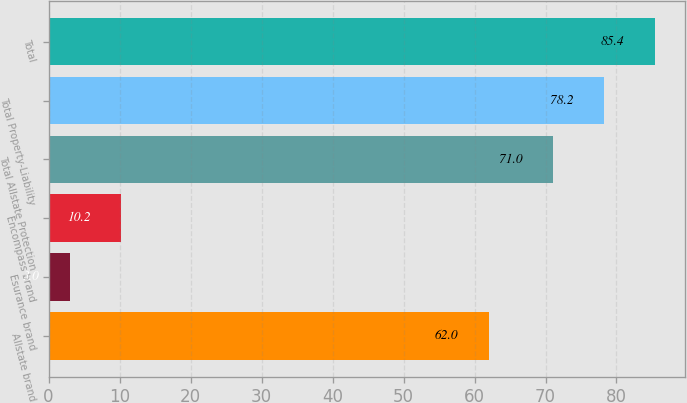Convert chart to OTSL. <chart><loc_0><loc_0><loc_500><loc_500><bar_chart><fcel>Allstate brand<fcel>Esurance brand<fcel>Encompass brand<fcel>Total Allstate Protection<fcel>Total Property-Liability<fcel>Total<nl><fcel>62<fcel>3<fcel>10.2<fcel>71<fcel>78.2<fcel>85.4<nl></chart> 